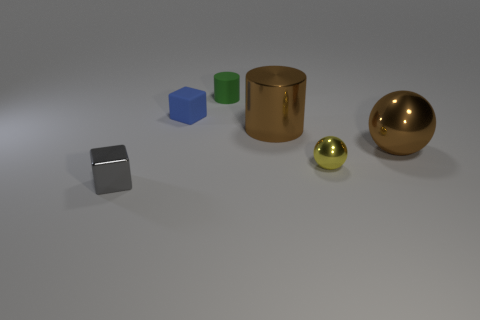What is the color of the tiny cube that is in front of the tiny shiny object that is on the right side of the small gray block? The tiny cube positioned in front of the tiny shiny object, which is to the right of the small gray block, is blue. 